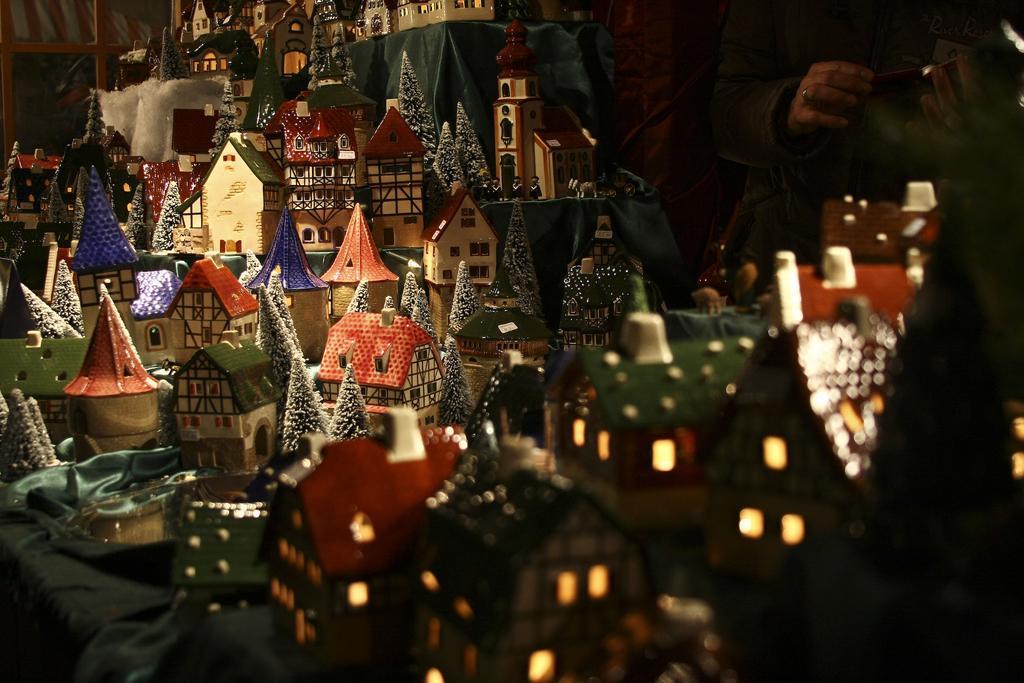How would you summarize this image in a sentence or two? In this image there are some toy houses and some lights and some objects, and on the right side there is one person. And in the background there are some other objects, and in the bottom right hand corner there is some cloth. 